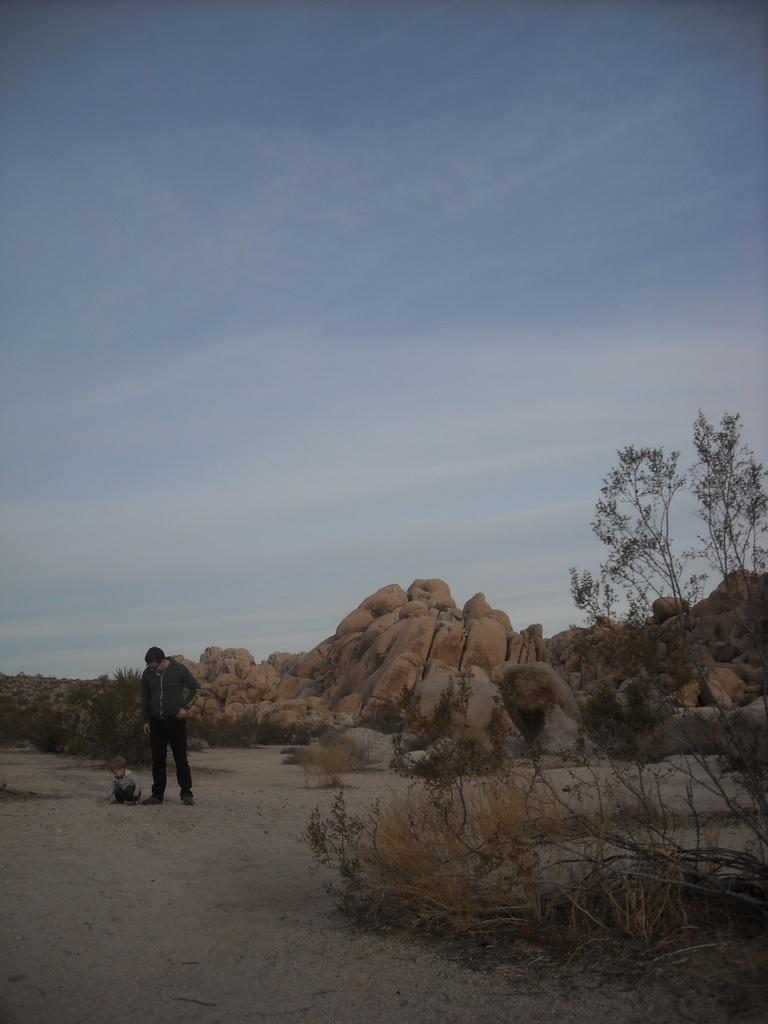What type of natural elements can be seen in the image? There are rocks and trees in the image. Can you describe the people in the image? There is a man standing and a boy in the image. What is the condition of the sky in the image? The sky is blue and cloudy in the image. What letters are the boy and man exchanging in the image? There are no letters visible in the image; it only shows rocks, trees, a man, and a boy. What type of breakfast is the man preparing for the boy in the image? There is no breakfast preparation or any food items present in the image. 